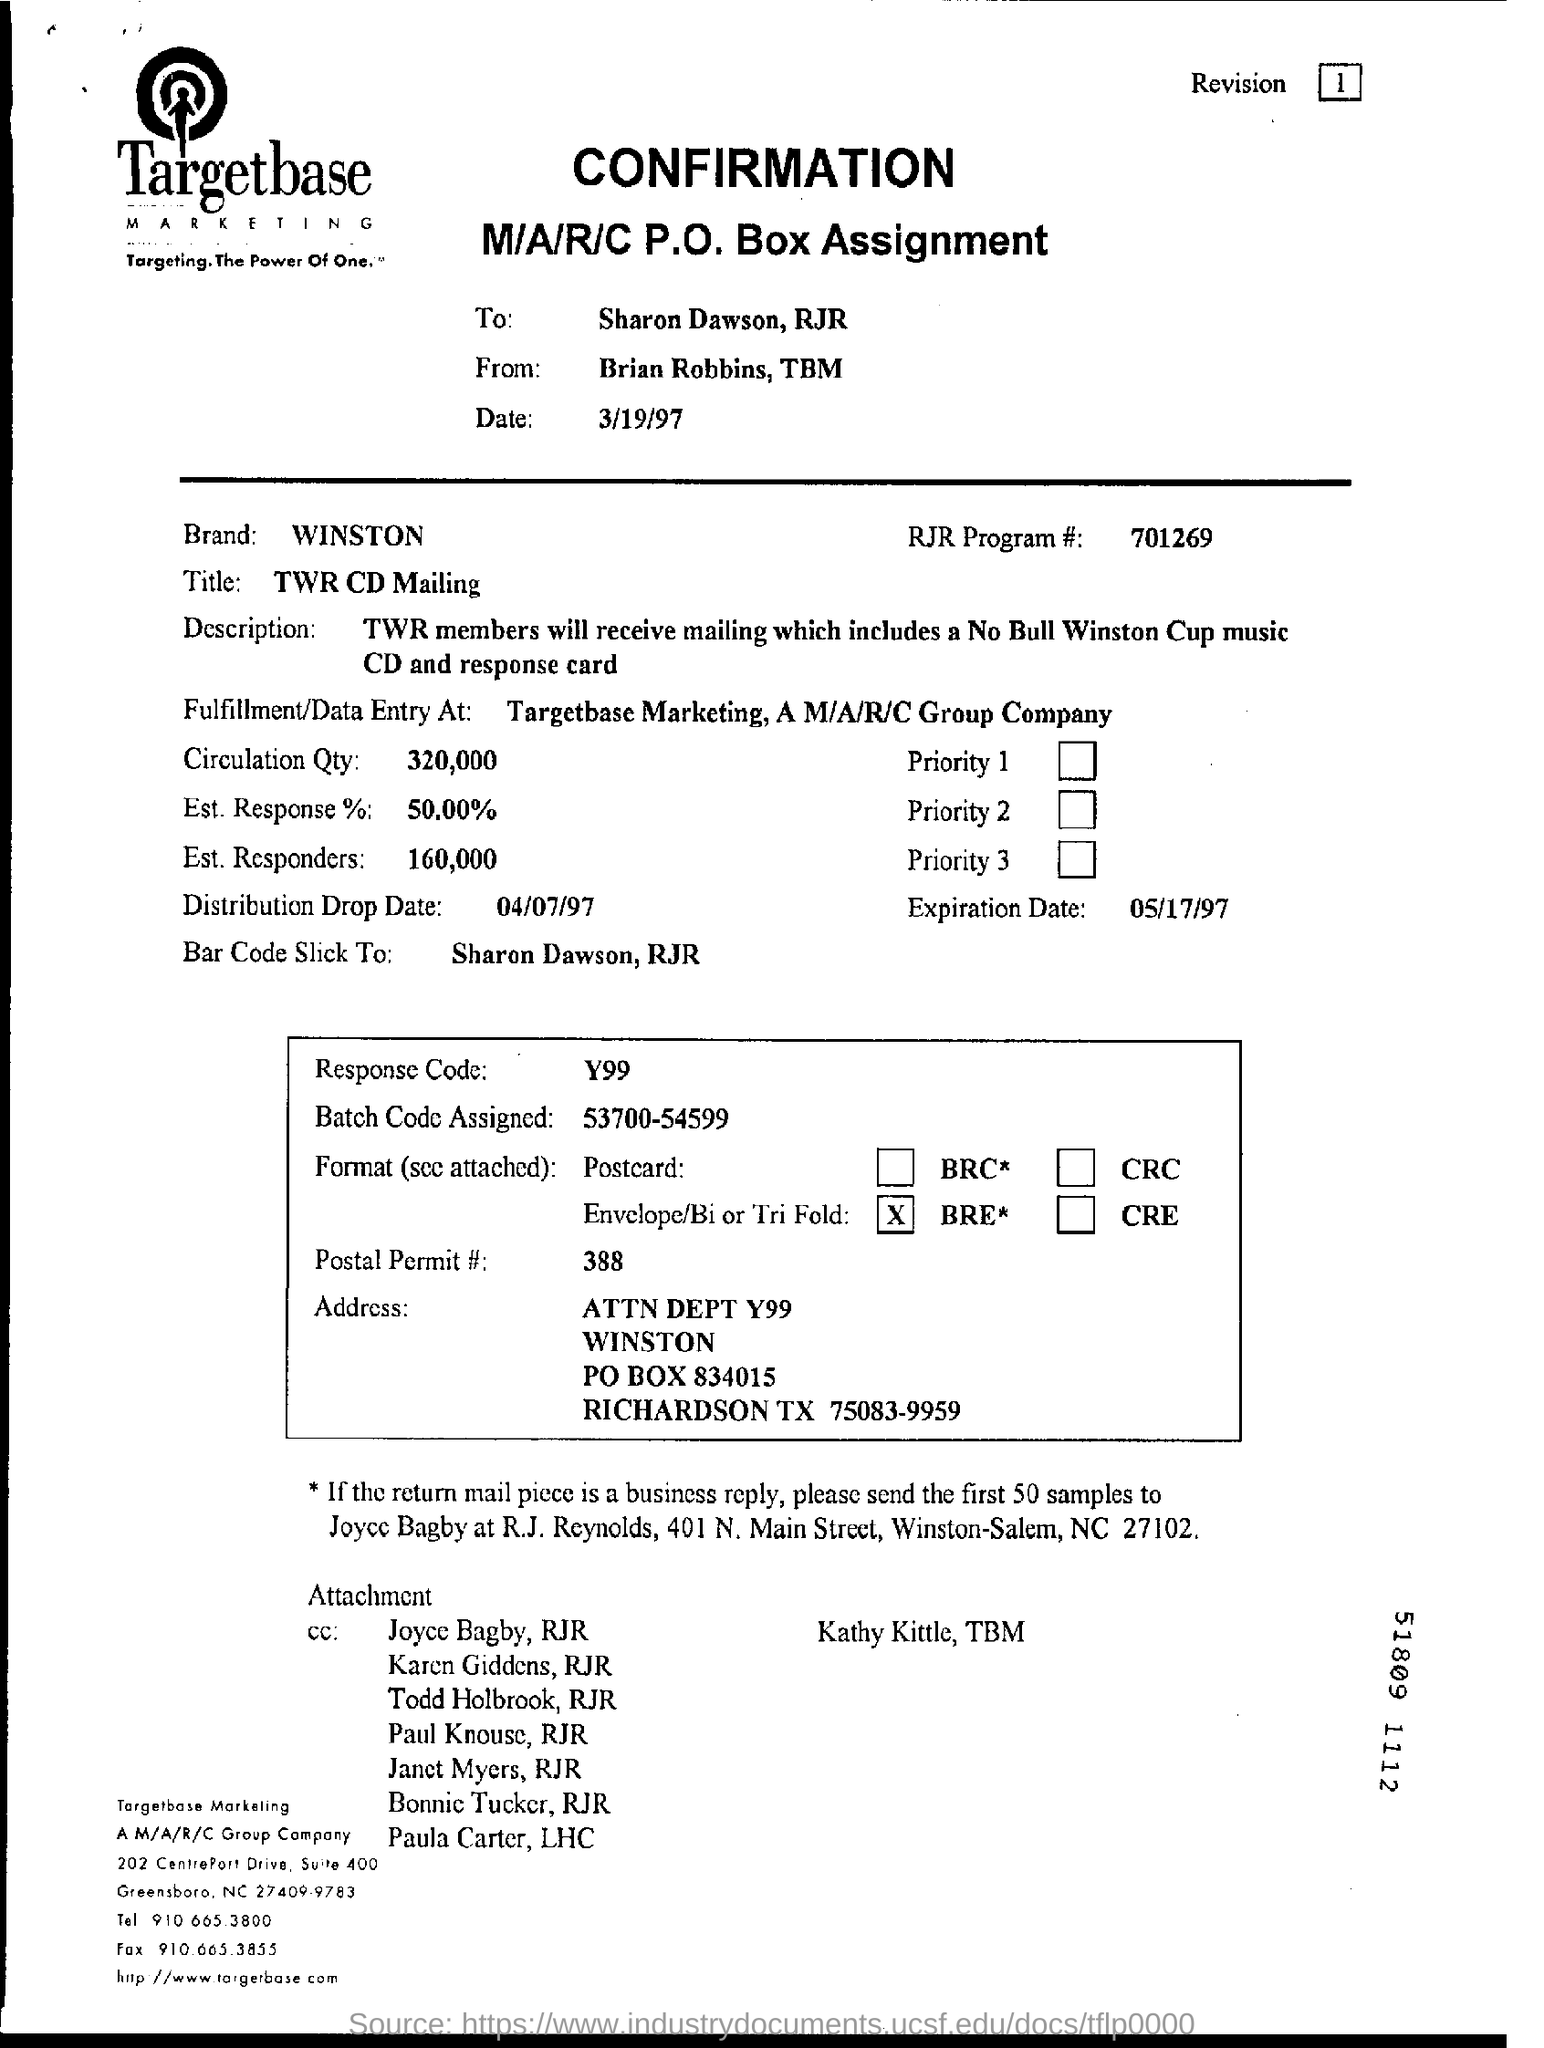How many number of estimated responders are mentioned?
Offer a terse response. 160,000. When is the distribution drop date?
Your answer should be compact. 04/07/97. When is the expiration date?
Offer a very short reply. 05/17/97. What is the name of the brand?
Provide a succinct answer. Winston. 